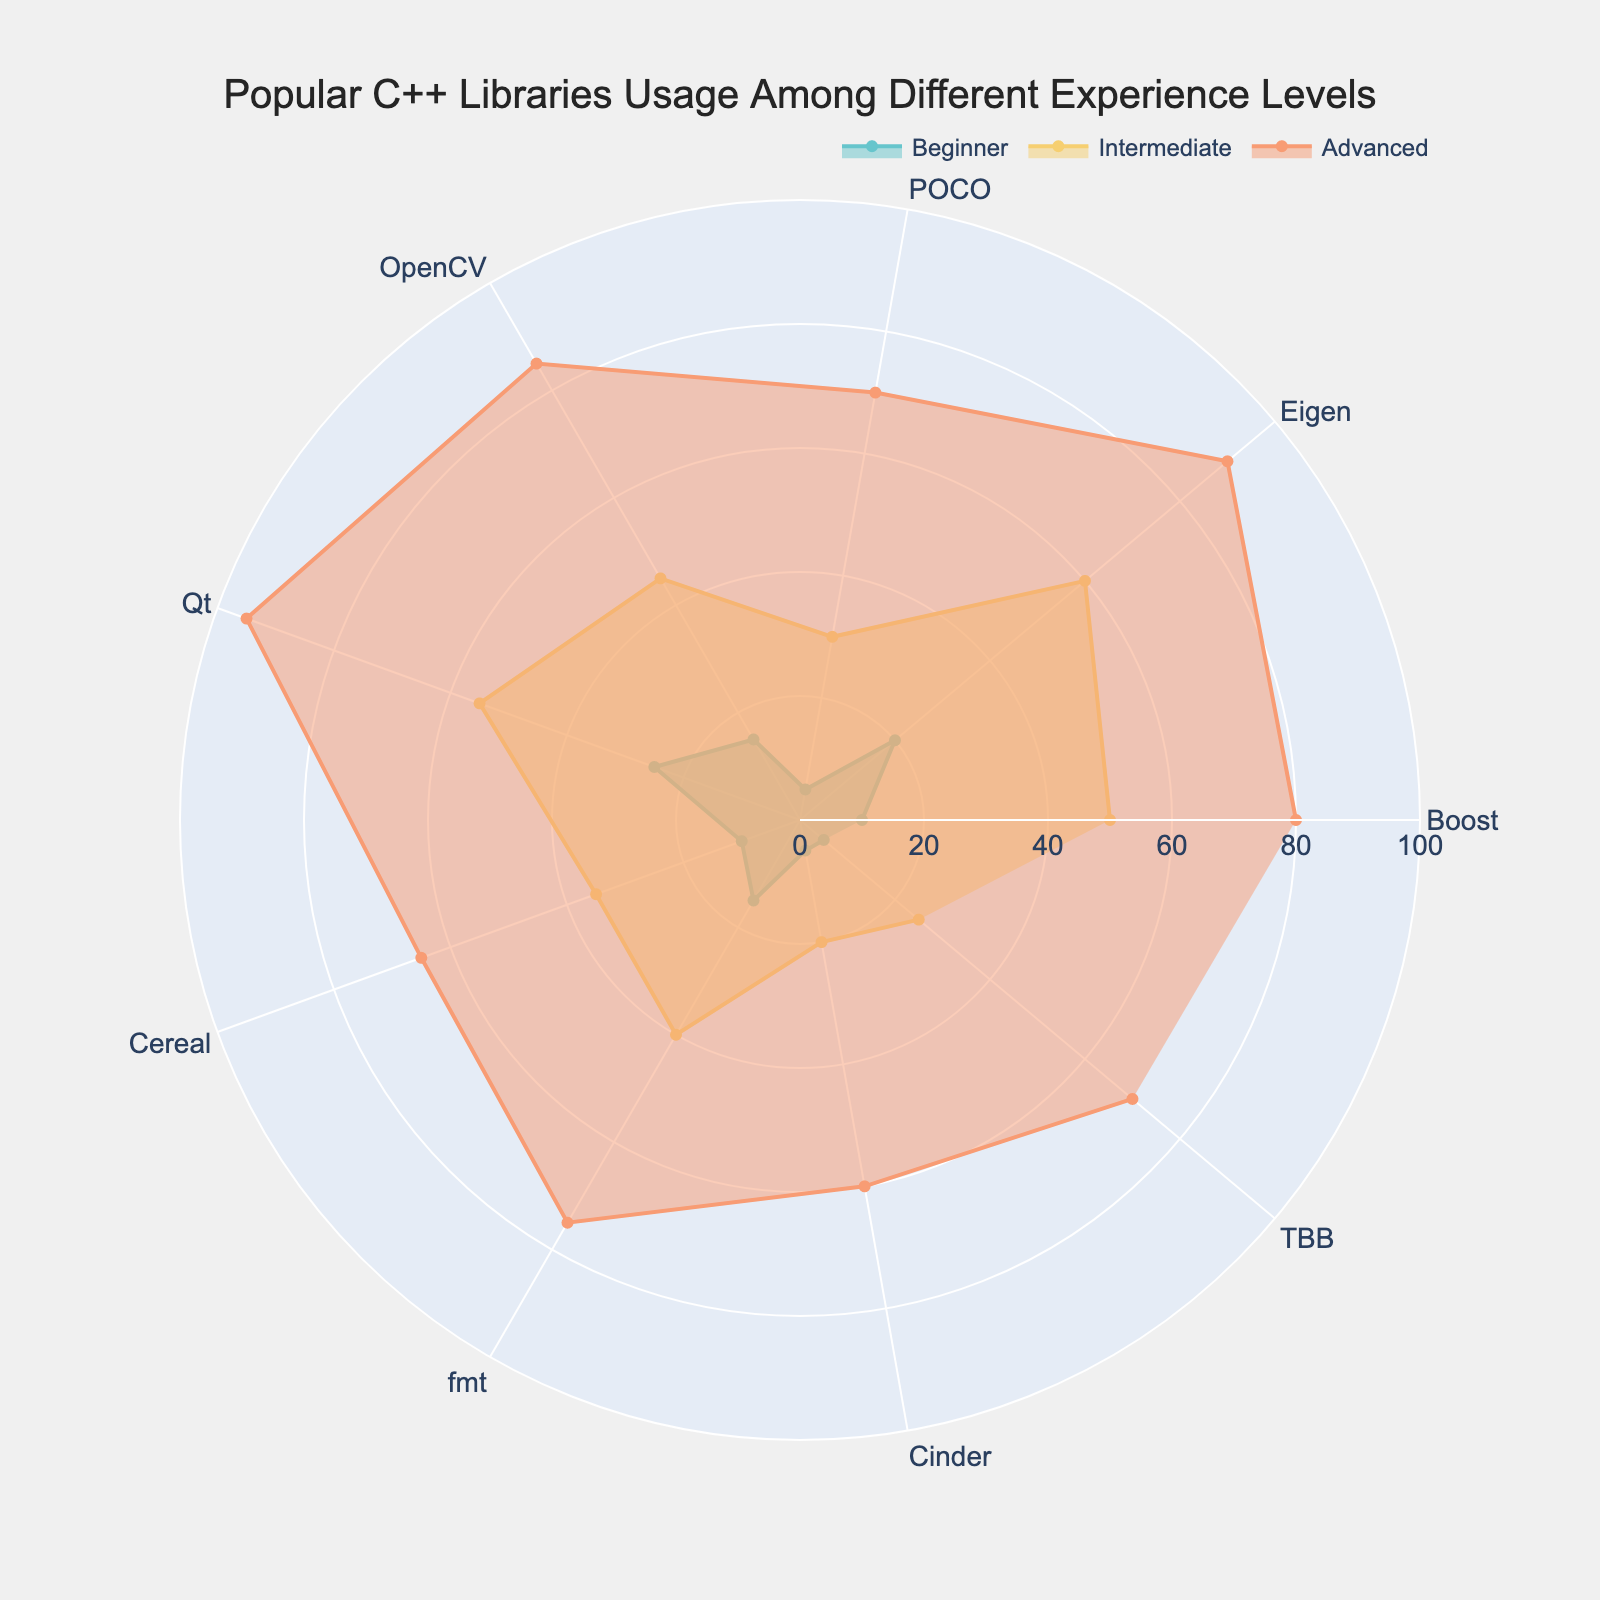What is the title of the polar chart? The title of the polar chart is located at the top center of the figure. By looking at this area, you can see the written text.
Answer: Popular C++ Libraries Usage Among Different Experience Levels Which experience level has the highest usage of the library OpenCV? Identify the OpenCV data point then compare the three radial values associated with each experience level (Beginner, Intermediate, Advanced). The highest value determines the experience level with the highest usage.
Answer: Advanced What are the colors assigned to each experience level? Look at the legend present in the chart, which is located above the chart area. Each color corresponds to an experience level.
Answer: Beginner: light blue, Intermediate: yellow, Advanced: orange Which library has the lowest usage among beginners? Review the radial values for each library under the "Beginner" label. Locate the library with the smallest radial value.
Answer: POCO What is the sum of usage percentages for the library Boost across all experience levels? Add the percentages of Boost usage for Beginner (10), Intermediate (50), and Advanced (80).
Answer: 140 Which library shows the least difference in usage between Beginners and Advanced users? Calculate the absolute difference in usage between Beginners and Advanced users for each library. The library with the smallest difference is the answer.
Answer: Cinder How does the usage of the library Qt compare between Intermediate and Advanced users? Compare the radial values of Intermediate and Advanced for the library Qt. Note which level has a greater value.
Answer: Higher for Advanced users What is the average usage percentage of beginner users across all libraries? Sum the “Beginner” radial values for all libraries and divide by the number of libraries. (10+20+5+15+25+10+15+5+5)/9
Answer: 12.22 Which library has the highest usage by Intermediate users? Check the “Intermediate” radial values for all libraries and identify the highest value.
Answer: Qt What is the range of usage percentages for advanced users? Identify the minimum and maximum radial values for "Advanced" users among all libraries and calculate the range by subtracting the minimum value from the maximum value.
Answer: 35 